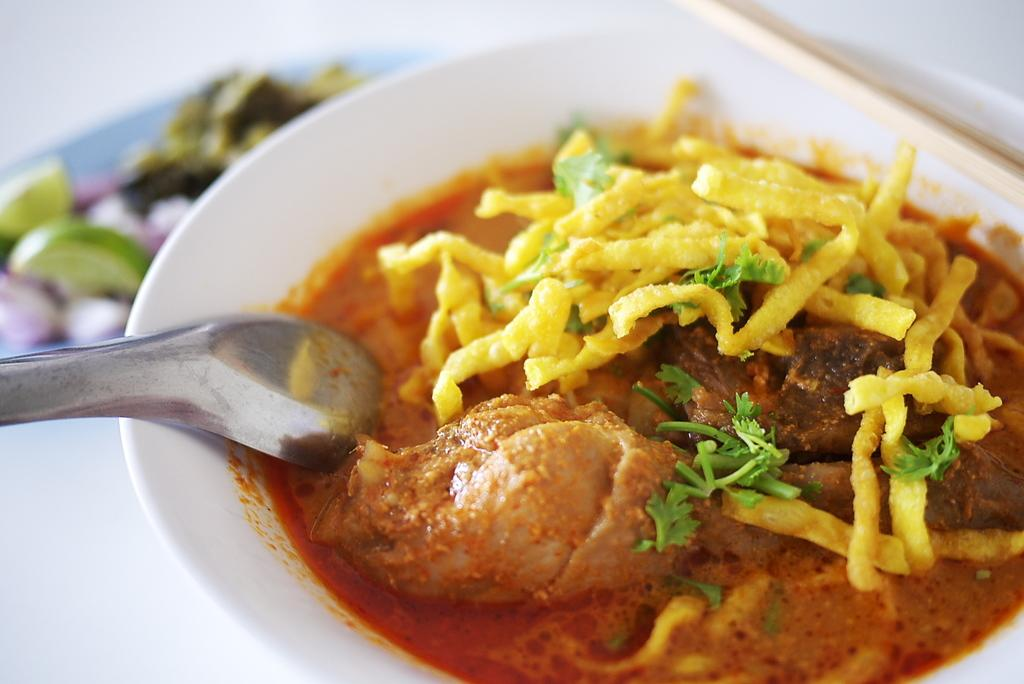What is in the bowl that is visible in the image? There are food items in a bowl in the image. What utensil is visible in the image? There is a spoon visible in the image. Where are the additional food items located in the image? The additional food items are placed on a table in the image. What type of kitten can be seen playing with the food items on the table in the image? There is no kitten present in the image; it only features food items, a spoon, and additional food items on a table. 